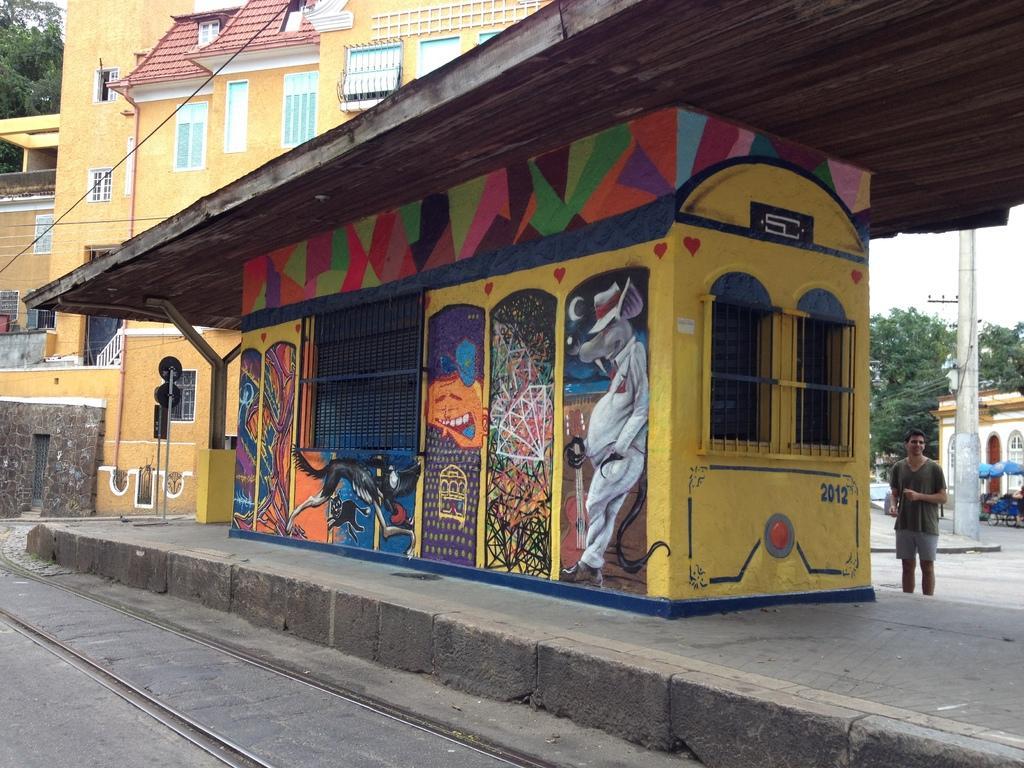Can you describe this image briefly? In the foreground of this picture, there is a room and also a platform where we can see a track on the left bottom corner. In the background, there is a man standing, trees, pole, sky and the buildings. 